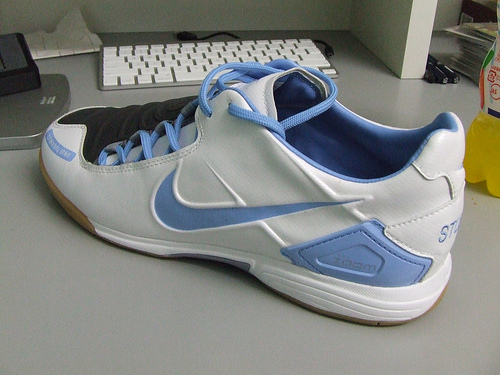<image>
Is the shoe under the keyboard? No. The shoe is not positioned under the keyboard. The vertical relationship between these objects is different. Where is the shoe in relation to the keyboard? Is it in front of the keyboard? Yes. The shoe is positioned in front of the keyboard, appearing closer to the camera viewpoint. 